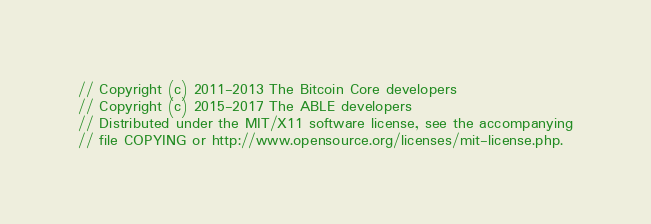Convert code to text. <code><loc_0><loc_0><loc_500><loc_500><_ObjectiveC_>// Copyright (c) 2011-2013 The Bitcoin Core developers
// Copyright (c) 2015-2017 The ABLE developers
// Distributed under the MIT/X11 software license, see the accompanying
// file COPYING or http://www.opensource.org/licenses/mit-license.php.
</code> 